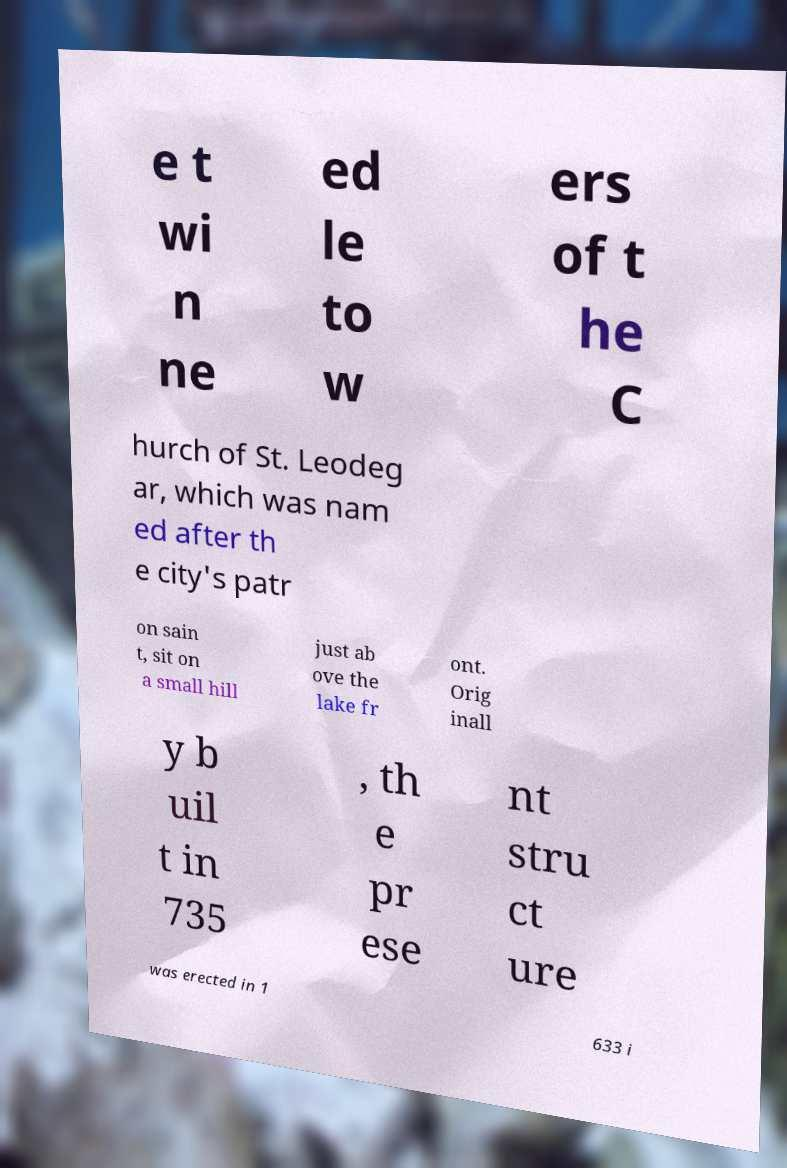There's text embedded in this image that I need extracted. Can you transcribe it verbatim? e t wi n ne ed le to w ers of t he C hurch of St. Leodeg ar, which was nam ed after th e city's patr on sain t, sit on a small hill just ab ove the lake fr ont. Orig inall y b uil t in 735 , th e pr ese nt stru ct ure was erected in 1 633 i 